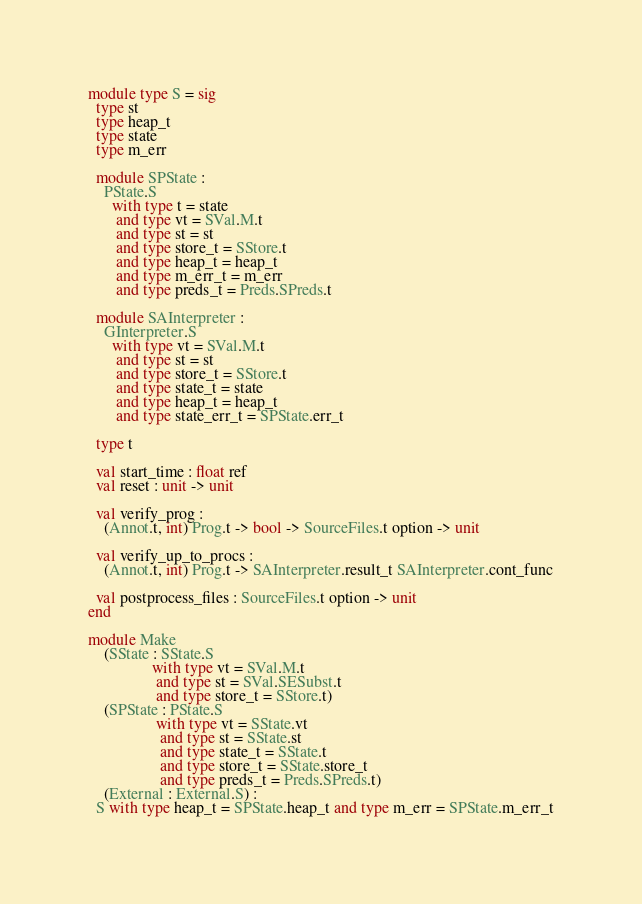Convert code to text. <code><loc_0><loc_0><loc_500><loc_500><_OCaml_>module type S = sig
  type st
  type heap_t
  type state
  type m_err

  module SPState :
    PState.S
      with type t = state
       and type vt = SVal.M.t
       and type st = st
       and type store_t = SStore.t
       and type heap_t = heap_t
       and type m_err_t = m_err
       and type preds_t = Preds.SPreds.t

  module SAInterpreter :
    GInterpreter.S
      with type vt = SVal.M.t
       and type st = st
       and type store_t = SStore.t
       and type state_t = state
       and type heap_t = heap_t
       and type state_err_t = SPState.err_t

  type t

  val start_time : float ref
  val reset : unit -> unit

  val verify_prog :
    (Annot.t, int) Prog.t -> bool -> SourceFiles.t option -> unit

  val verify_up_to_procs :
    (Annot.t, int) Prog.t -> SAInterpreter.result_t SAInterpreter.cont_func

  val postprocess_files : SourceFiles.t option -> unit
end

module Make
    (SState : SState.S
                with type vt = SVal.M.t
                 and type st = SVal.SESubst.t
                 and type store_t = SStore.t)
    (SPState : PState.S
                 with type vt = SState.vt
                  and type st = SState.st
                  and type state_t = SState.t
                  and type store_t = SState.store_t
                  and type preds_t = Preds.SPreds.t)
    (External : External.S) :
  S with type heap_t = SPState.heap_t and type m_err = SPState.m_err_t
</code> 